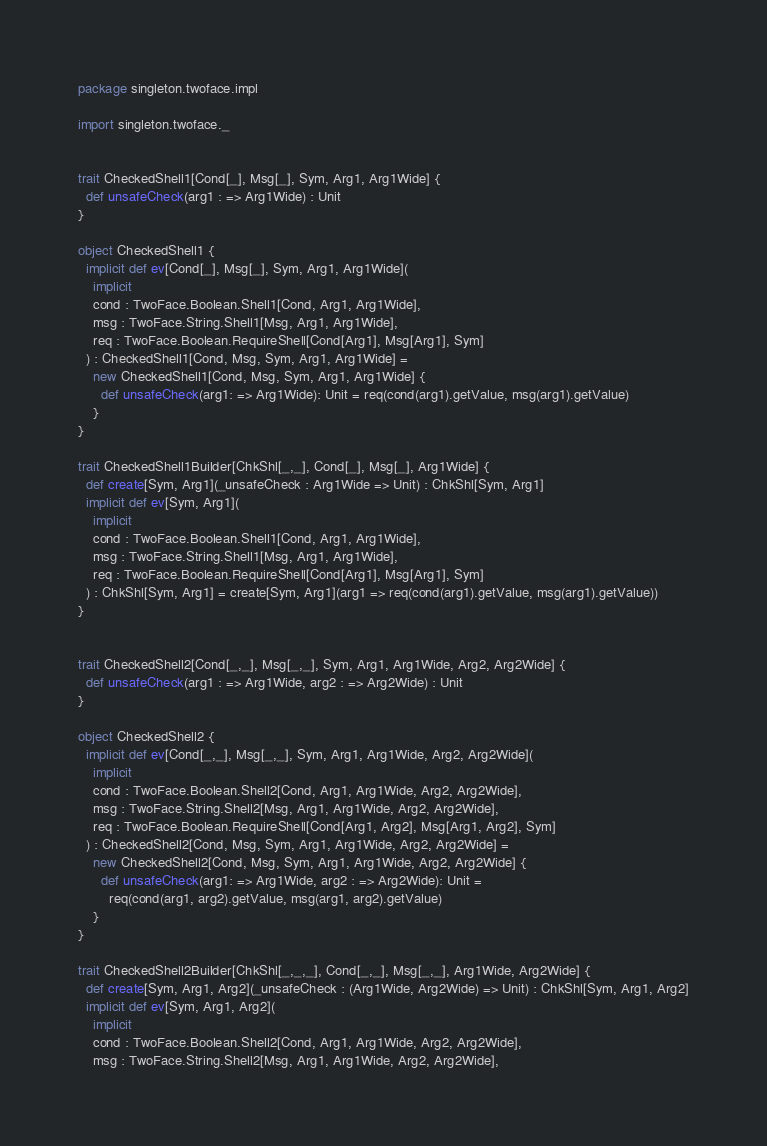Convert code to text. <code><loc_0><loc_0><loc_500><loc_500><_Scala_>package singleton.twoface.impl

import singleton.twoface._


trait CheckedShell1[Cond[_], Msg[_], Sym, Arg1, Arg1Wide] {
  def unsafeCheck(arg1 : => Arg1Wide) : Unit
}

object CheckedShell1 {
  implicit def ev[Cond[_], Msg[_], Sym, Arg1, Arg1Wide](
    implicit
    cond : TwoFace.Boolean.Shell1[Cond, Arg1, Arg1Wide],
    msg : TwoFace.String.Shell1[Msg, Arg1, Arg1Wide],
    req : TwoFace.Boolean.RequireShell[Cond[Arg1], Msg[Arg1], Sym]
  ) : CheckedShell1[Cond, Msg, Sym, Arg1, Arg1Wide] =
    new CheckedShell1[Cond, Msg, Sym, Arg1, Arg1Wide] {
      def unsafeCheck(arg1: => Arg1Wide): Unit = req(cond(arg1).getValue, msg(arg1).getValue)
    }
}

trait CheckedShell1Builder[ChkShl[_,_], Cond[_], Msg[_], Arg1Wide] {
  def create[Sym, Arg1](_unsafeCheck : Arg1Wide => Unit) : ChkShl[Sym, Arg1]
  implicit def ev[Sym, Arg1](
    implicit
    cond : TwoFace.Boolean.Shell1[Cond, Arg1, Arg1Wide],
    msg : TwoFace.String.Shell1[Msg, Arg1, Arg1Wide],
    req : TwoFace.Boolean.RequireShell[Cond[Arg1], Msg[Arg1], Sym]
  ) : ChkShl[Sym, Arg1] = create[Sym, Arg1](arg1 => req(cond(arg1).getValue, msg(arg1).getValue))
}


trait CheckedShell2[Cond[_,_], Msg[_,_], Sym, Arg1, Arg1Wide, Arg2, Arg2Wide] {
  def unsafeCheck(arg1 : => Arg1Wide, arg2 : => Arg2Wide) : Unit
}

object CheckedShell2 {
  implicit def ev[Cond[_,_], Msg[_,_], Sym, Arg1, Arg1Wide, Arg2, Arg2Wide](
    implicit
    cond : TwoFace.Boolean.Shell2[Cond, Arg1, Arg1Wide, Arg2, Arg2Wide],
    msg : TwoFace.String.Shell2[Msg, Arg1, Arg1Wide, Arg2, Arg2Wide],
    req : TwoFace.Boolean.RequireShell[Cond[Arg1, Arg2], Msg[Arg1, Arg2], Sym]
  ) : CheckedShell2[Cond, Msg, Sym, Arg1, Arg1Wide, Arg2, Arg2Wide] =
    new CheckedShell2[Cond, Msg, Sym, Arg1, Arg1Wide, Arg2, Arg2Wide] {
      def unsafeCheck(arg1: => Arg1Wide, arg2 : => Arg2Wide): Unit =
        req(cond(arg1, arg2).getValue, msg(arg1, arg2).getValue)
    }
}

trait CheckedShell2Builder[ChkShl[_,_,_], Cond[_,_], Msg[_,_], Arg1Wide, Arg2Wide] {
  def create[Sym, Arg1, Arg2](_unsafeCheck : (Arg1Wide, Arg2Wide) => Unit) : ChkShl[Sym, Arg1, Arg2]
  implicit def ev[Sym, Arg1, Arg2](
    implicit
    cond : TwoFace.Boolean.Shell2[Cond, Arg1, Arg1Wide, Arg2, Arg2Wide],
    msg : TwoFace.String.Shell2[Msg, Arg1, Arg1Wide, Arg2, Arg2Wide],</code> 